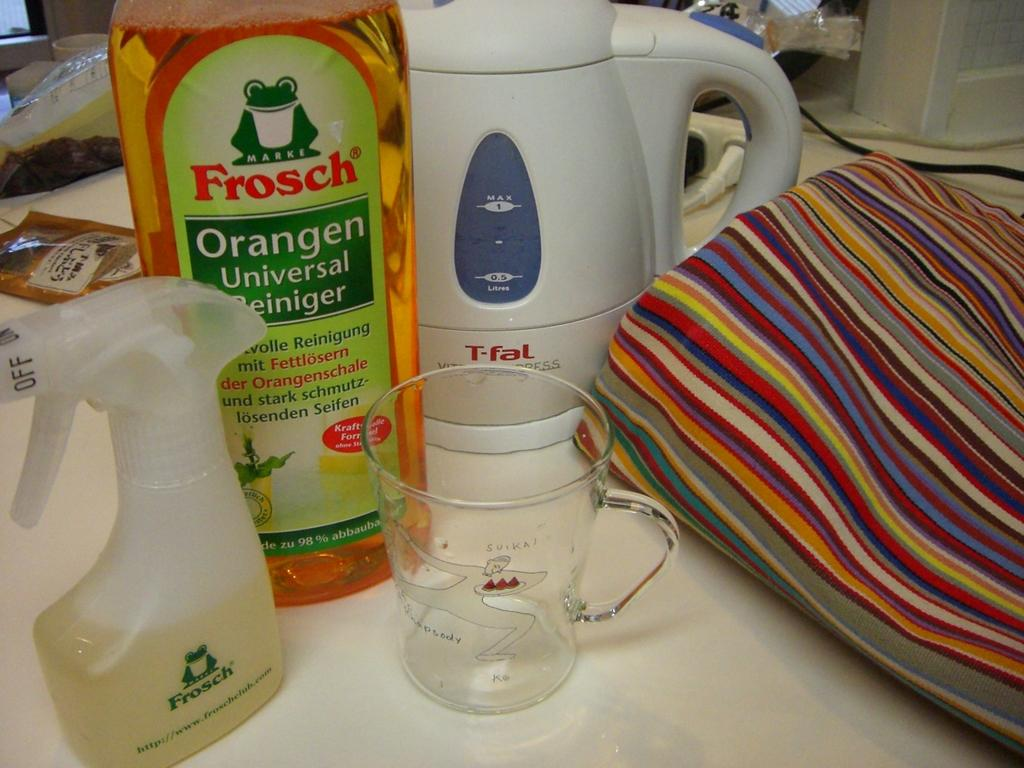<image>
Share a concise interpretation of the image provided. Frosch Orangen Universal Reiniger is ready to be diluted in the measuring cup and placed into the spray bottle. 